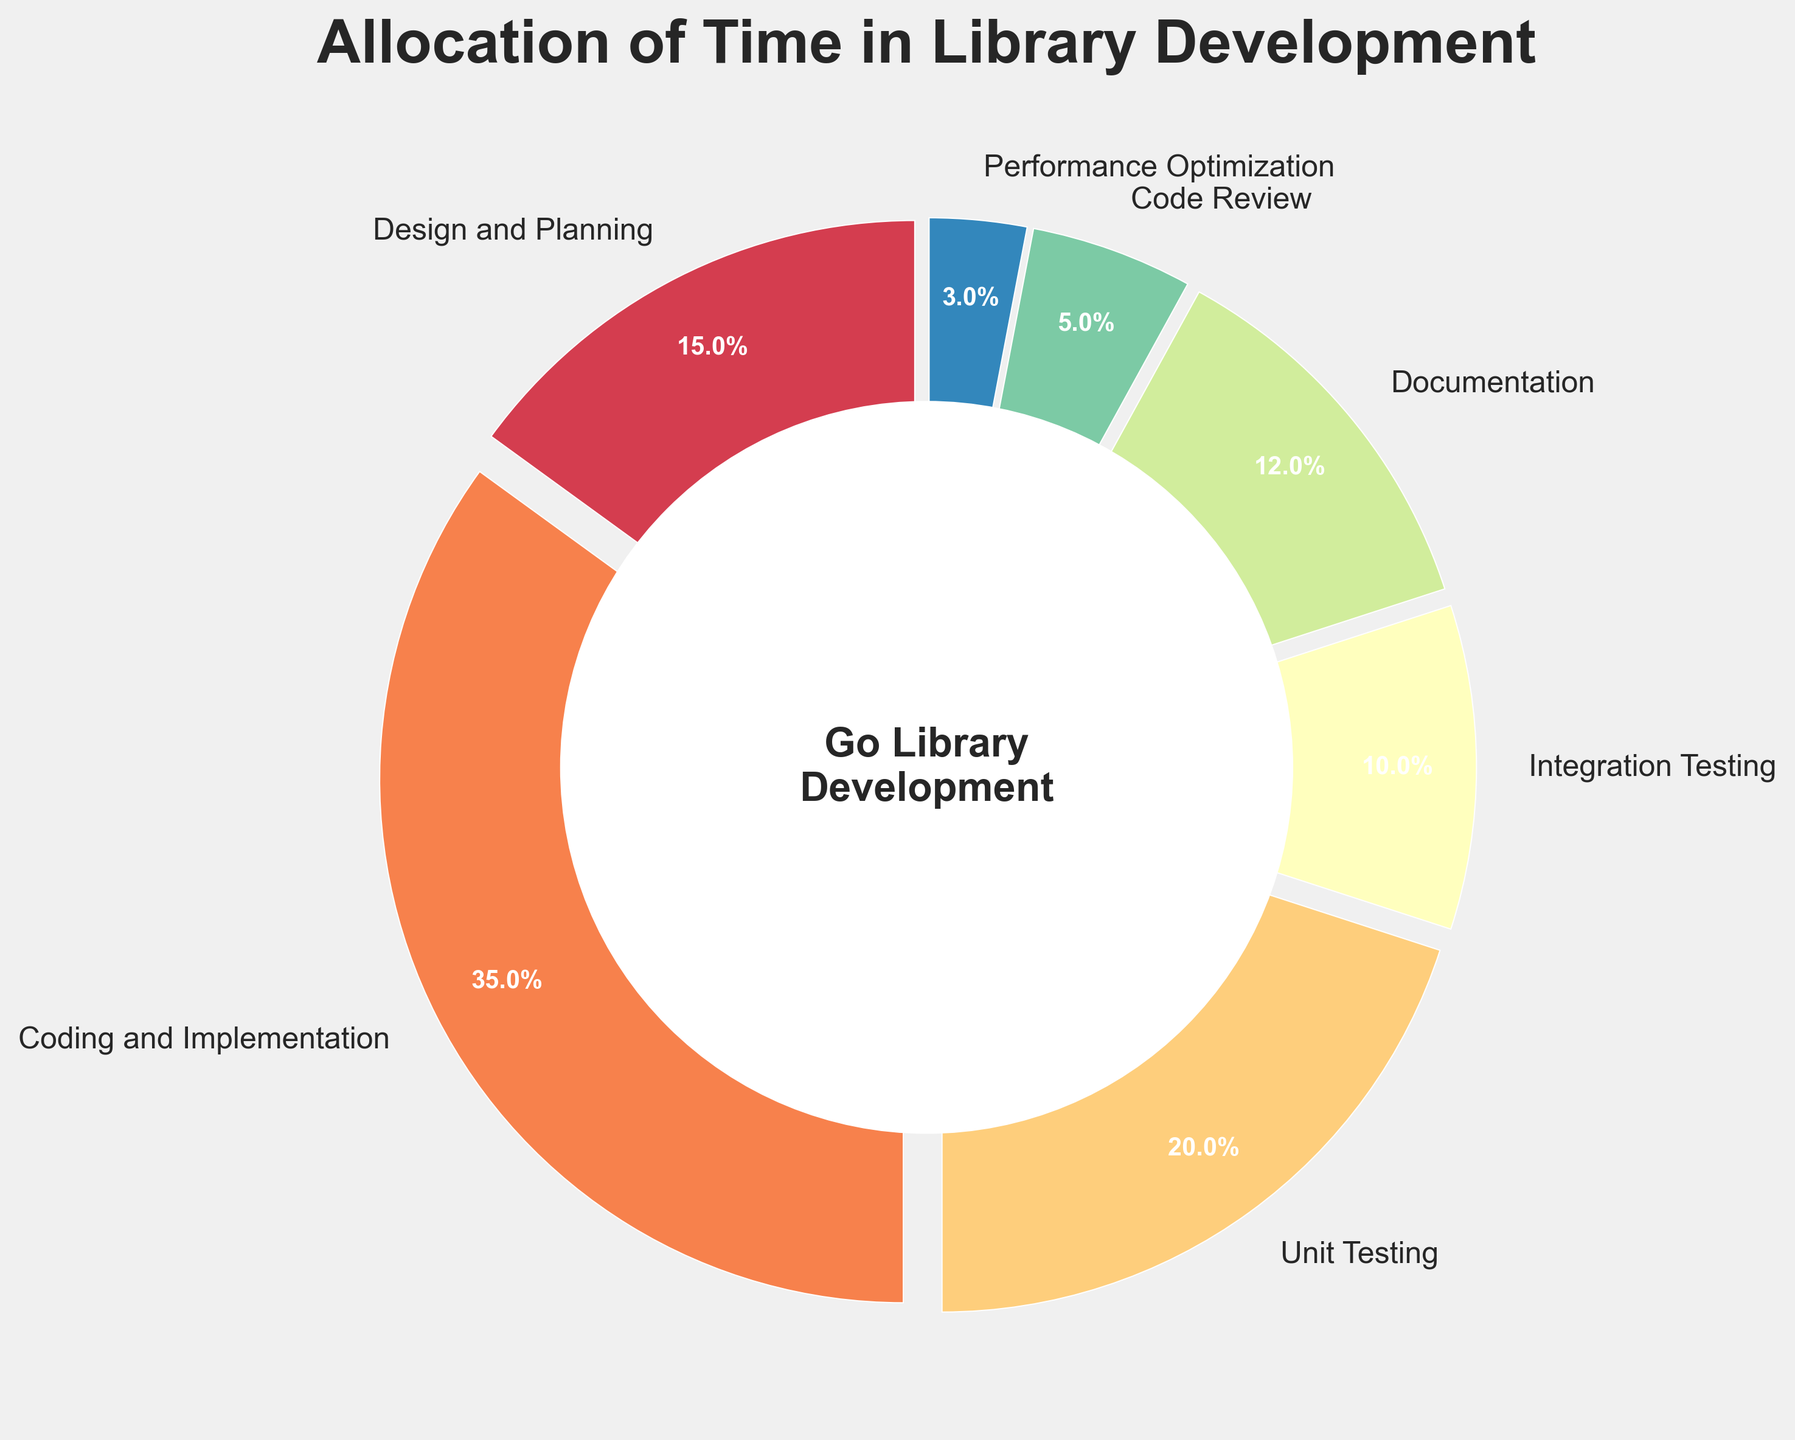What phase has the highest percentage allocation in library development? The coding and implementation phase has the highest percentage, as visually its wedge is the largest and its percentage is visible as 35%
Answer: Coding and Implementation What percentage of time is allocated to testing (Unit Testing + Integration Testing)? The chart shows that unit testing has 20% and integration testing has 10%. Adding these together gives 20% + 10% = 30%
Answer: 30% Which phases have a lower percentage allocation than Documentation? Documentation is labeled at 12%. Phases with a lower percentage are Integration Testing (10%), Code Review (5%), and Performance Optimization (3%)
Answer: Integration Testing, Code Review, Performance Optimization What is the total percentage of time spent on non-coding activities (Design and Planning, Unit Testing, Documentation, Code Review, Performance Optimization)? The percentages are 15% (Design and Planning) + 20% (Unit Testing) + 12% (Documentation) + 5% (Code Review) + 3% (Performance Optimization). Summing these gives 15% + 20% + 12% + 5% + 3% = 55%
Answer: 55% Which phase has the smallest allocation and what is its percentage? The smallest wedge in the chart corresponds to Performance Optimization, which is labeled as 3%
Answer: Performance Optimization, 3% How does the percentage of time spent on Integration Testing compare to that on Unit Testing? Integration Testing shows a 10% allocation, while Unit Testing shows 20%. Integration Testing is half of Unit Testing: 10% < 20%
Answer: Integration Testing is half of Unit Testing (%) Is the Design and Planning phase percentage greater than the Documentation phase? The Design and Planning phase is marked as 15% while the Documentation phase is marked as 12%. Therefore, Design and Planning is greater
Answer: Yes What is the combined allocation of Coding and Implementation, and Code Review? The percentages are 35% (Coding and Implementation) + 5% (Code Review). Adding these together gives 35% + 5% = 40%
Answer: 40% How does the allocation for Unit Testing compare visually to that for Documentation? Unit Testing has a larger wedge than Documentation. Unit Testing is marked as 20%, while Documentation is marked as 12%
Answer: Unit Testing is larger 